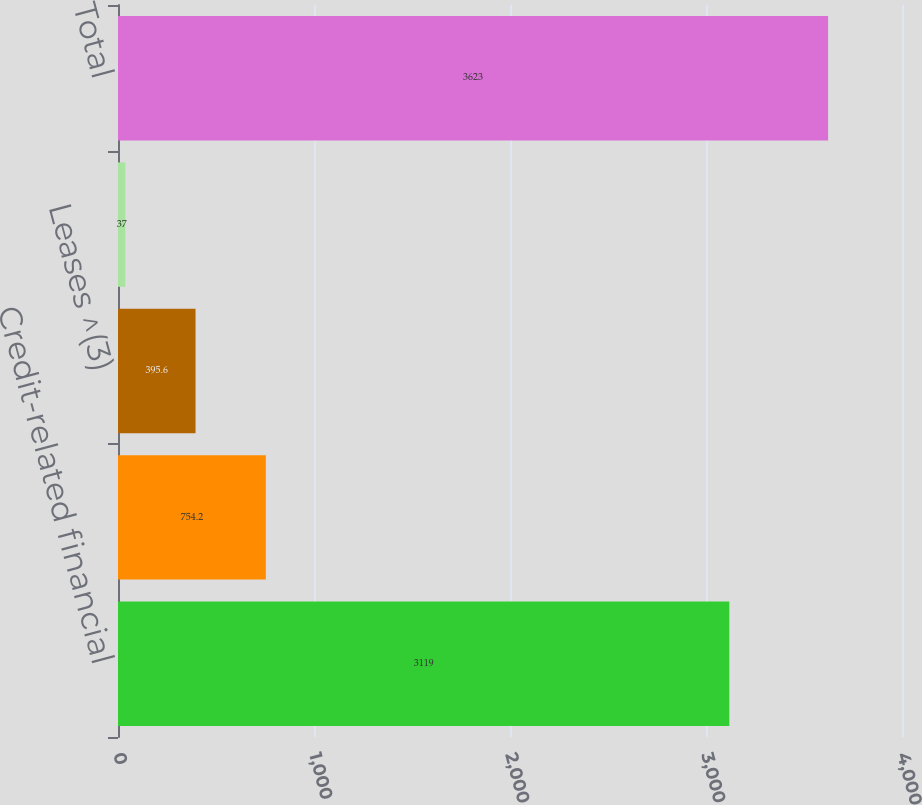Convert chart to OTSL. <chart><loc_0><loc_0><loc_500><loc_500><bar_chart><fcel>Credit-related financial<fcel>Long-term debt ^(2)<fcel>Leases ^(3)<fcel>Purchase obligations ^(4)<fcel>Total<nl><fcel>3119<fcel>754.2<fcel>395.6<fcel>37<fcel>3623<nl></chart> 